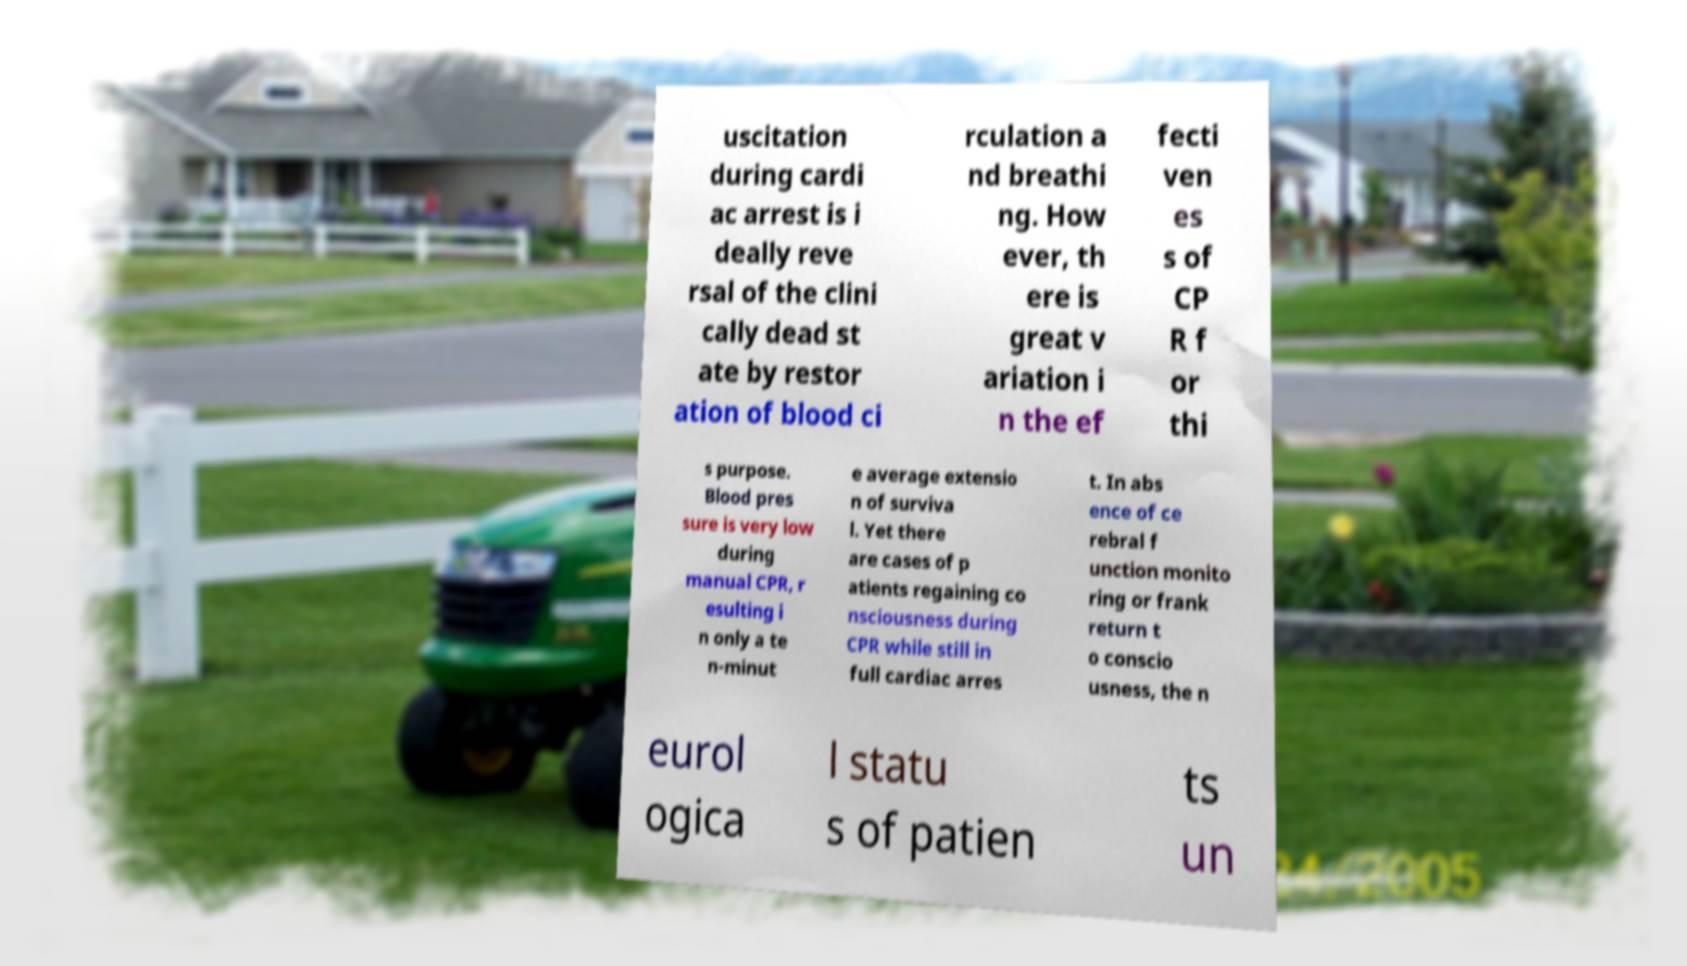Please read and relay the text visible in this image. What does it say? uscitation during cardi ac arrest is i deally reve rsal of the clini cally dead st ate by restor ation of blood ci rculation a nd breathi ng. How ever, th ere is great v ariation i n the ef fecti ven es s of CP R f or thi s purpose. Blood pres sure is very low during manual CPR, r esulting i n only a te n-minut e average extensio n of surviva l. Yet there are cases of p atients regaining co nsciousness during CPR while still in full cardiac arres t. In abs ence of ce rebral f unction monito ring or frank return t o conscio usness, the n eurol ogica l statu s of patien ts un 